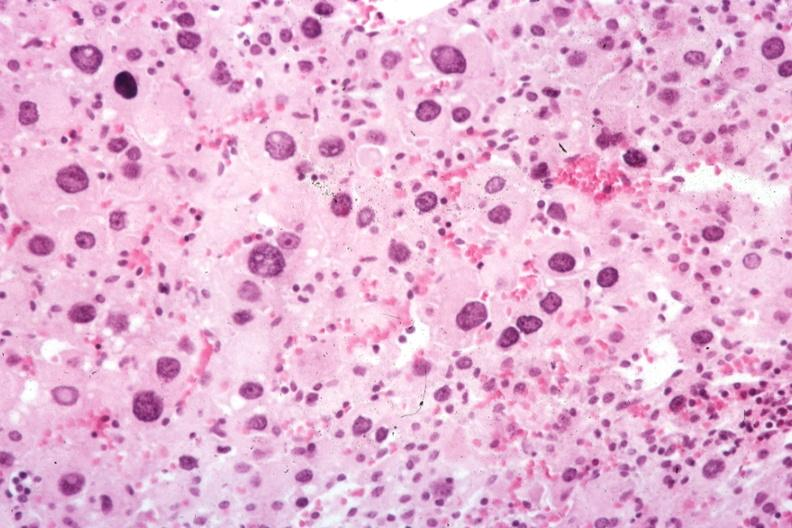s adrenal present?
Answer the question using a single word or phrase. Yes 